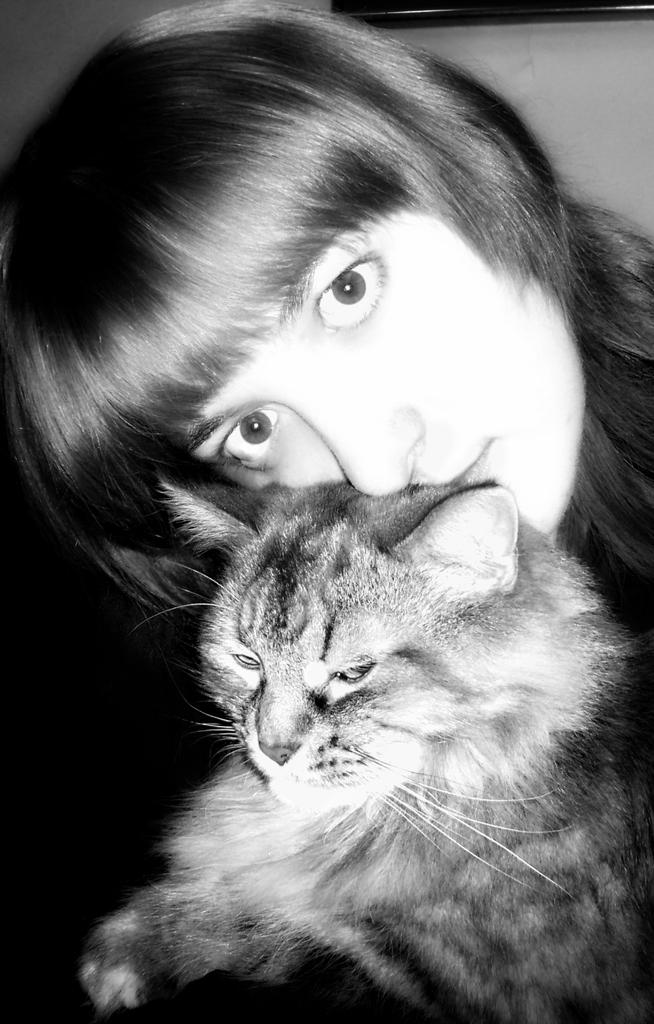Who or what can be seen in the image? There is a person and a cat in the image. Can you describe the person in the image? Unfortunately, the provided facts do not give any details about the person's appearance or clothing. How is the cat positioned in the image? The facts do not specify the cat's position or posture. What is the relationship between the person and the cat in the image? The facts do not provide any information about their relationship or interaction. What type of steel is used to construct the cat's collar in the image? There is no mention of a collar or any steel in the image, as it features a person and a cat without any specific details about their appearance or accessories. 